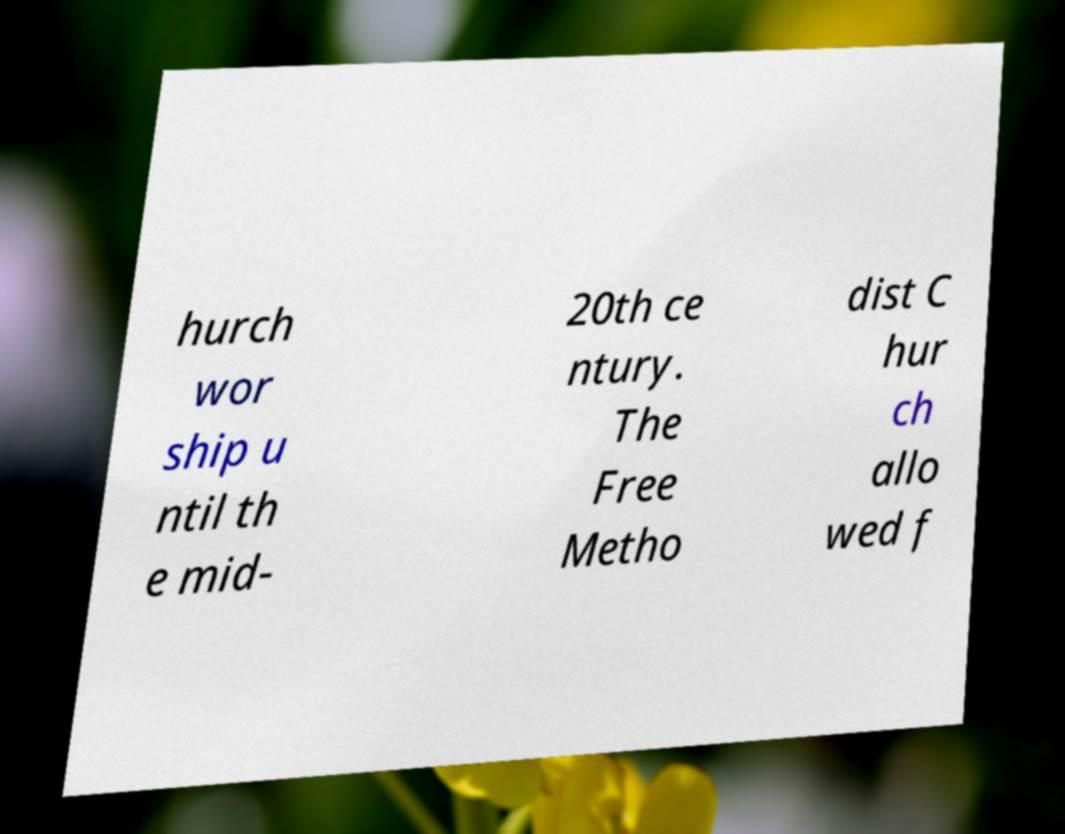I need the written content from this picture converted into text. Can you do that? hurch wor ship u ntil th e mid- 20th ce ntury. The Free Metho dist C hur ch allo wed f 